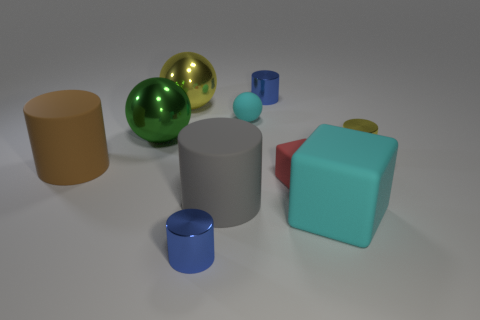What size is the rubber block that is the same color as the small matte ball?
Ensure brevity in your answer.  Large. What is the shape of the thing that is the same color as the large cube?
Provide a short and direct response. Sphere. Is there a red matte thing of the same size as the green sphere?
Your answer should be compact. No. What is the material of the small blue thing that is behind the small rubber thing to the right of the tiny blue shiny object behind the large green metallic ball?
Your response must be concise. Metal. How many tiny blue cylinders are behind the small object that is on the right side of the large matte block?
Give a very brief answer. 1. There is a metallic thing that is in front of the yellow cylinder; does it have the same size as the brown rubber object?
Give a very brief answer. No. What number of tiny yellow things are the same shape as the big green thing?
Your answer should be very brief. 0. There is a tiny yellow shiny thing; what shape is it?
Offer a very short reply. Cylinder. Are there an equal number of large rubber objects behind the tiny yellow shiny thing and large brown cylinders?
Offer a very short reply. No. Is the large cylinder behind the tiny matte block made of the same material as the large gray object?
Make the answer very short. Yes. 